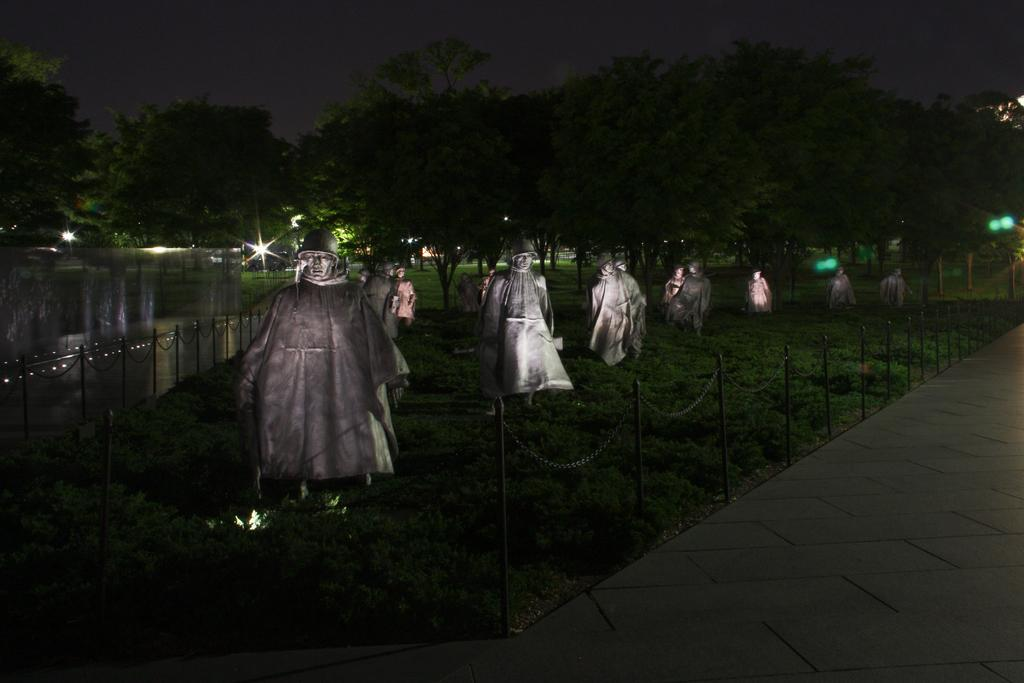What can be seen in the image? There are statues in the image. Where are the statues located? The statues are placed on a greenery ground. What is in front of the statues? There is a fence in front of the statues. What can be seen in the background of the image? There are trees and lights in the background of the image. How many weeks have passed since the person last visited the statues in the image? There is no person present in the image, so it is impossible to determine how many weeks have passed since their last visit. 